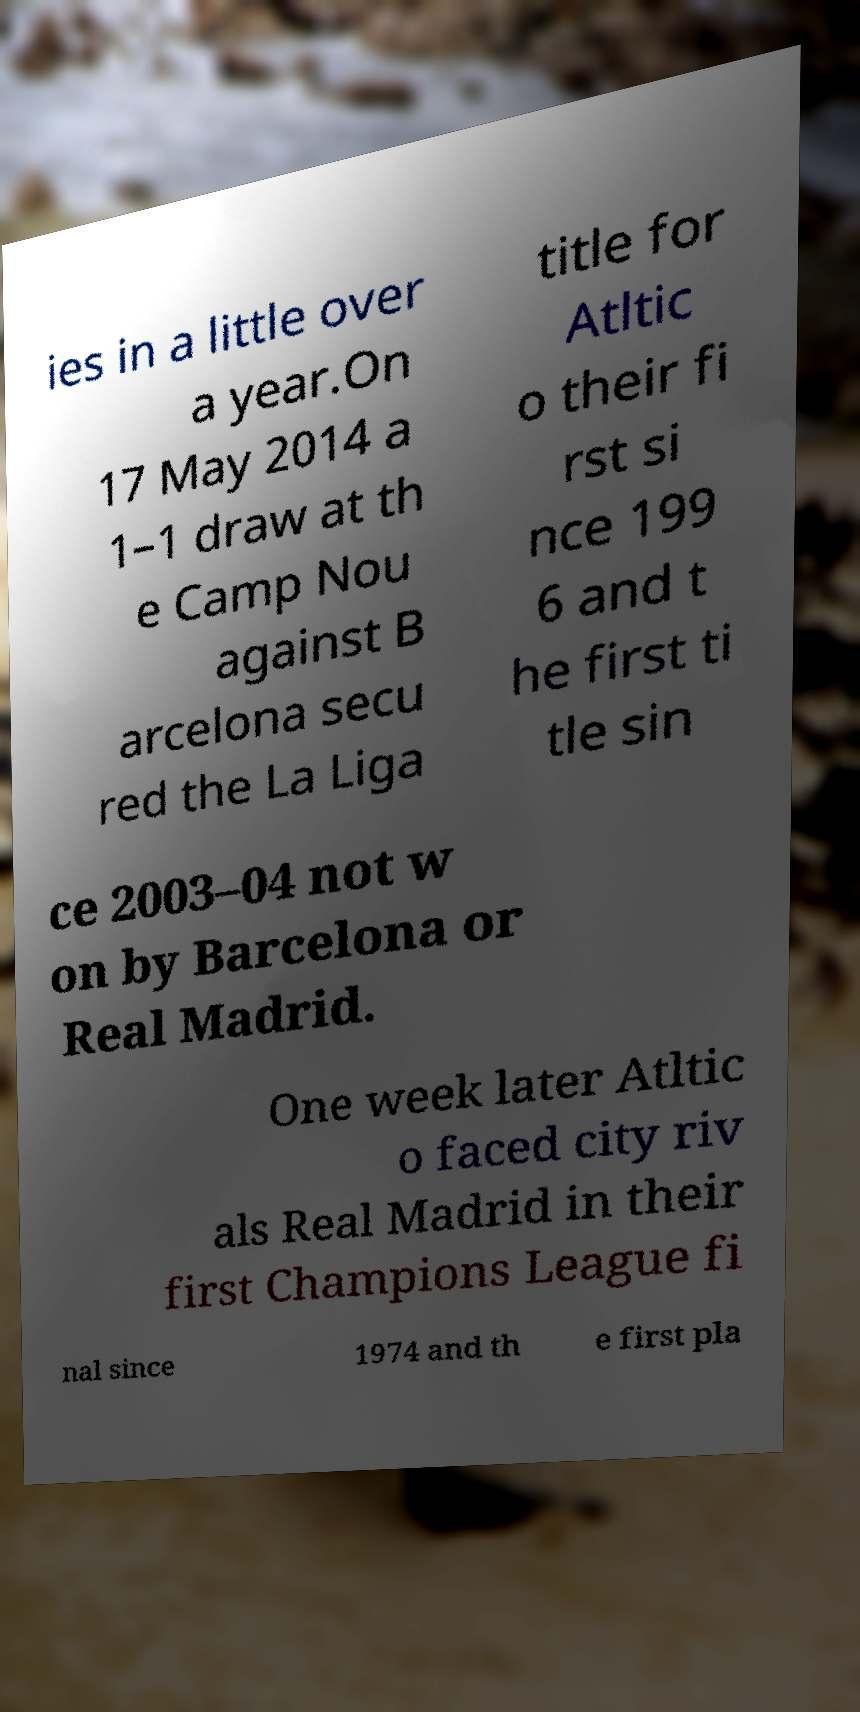Could you extract and type out the text from this image? ies in a little over a year.On 17 May 2014 a 1–1 draw at th e Camp Nou against B arcelona secu red the La Liga title for Atltic o their fi rst si nce 199 6 and t he first ti tle sin ce 2003–04 not w on by Barcelona or Real Madrid. One week later Atltic o faced city riv als Real Madrid in their first Champions League fi nal since 1974 and th e first pla 